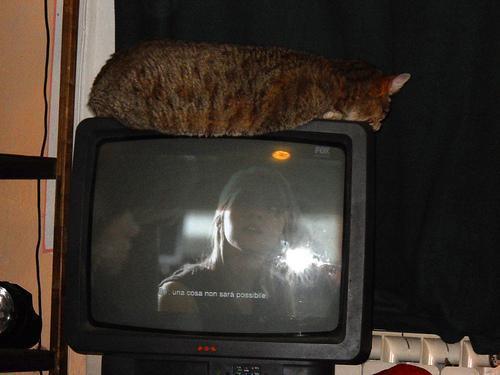How many cats?
Give a very brief answer. 1. 